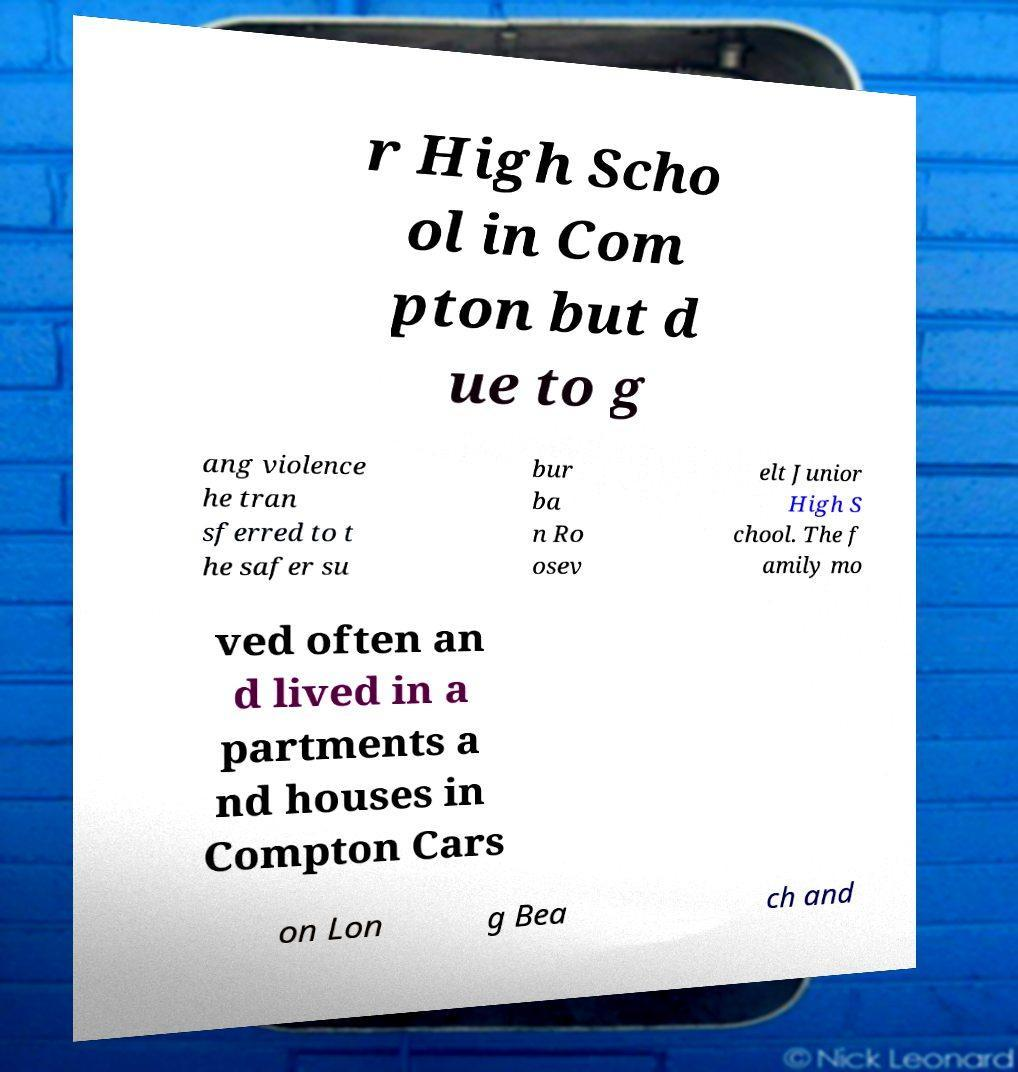Could you assist in decoding the text presented in this image and type it out clearly? r High Scho ol in Com pton but d ue to g ang violence he tran sferred to t he safer su bur ba n Ro osev elt Junior High S chool. The f amily mo ved often an d lived in a partments a nd houses in Compton Cars on Lon g Bea ch and 